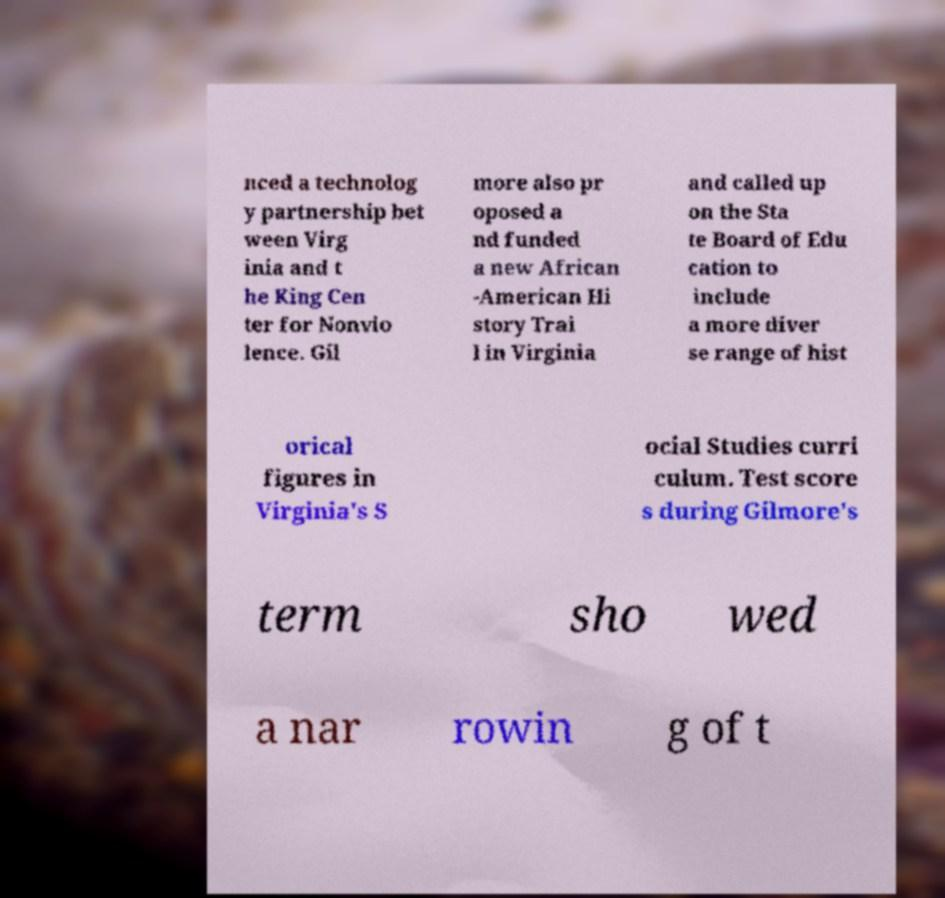Could you assist in decoding the text presented in this image and type it out clearly? nced a technolog y partnership bet ween Virg inia and t he King Cen ter for Nonvio lence. Gil more also pr oposed a nd funded a new African -American Hi story Trai l in Virginia and called up on the Sta te Board of Edu cation to include a more diver se range of hist orical figures in Virginia's S ocial Studies curri culum. Test score s during Gilmore's term sho wed a nar rowin g of t 